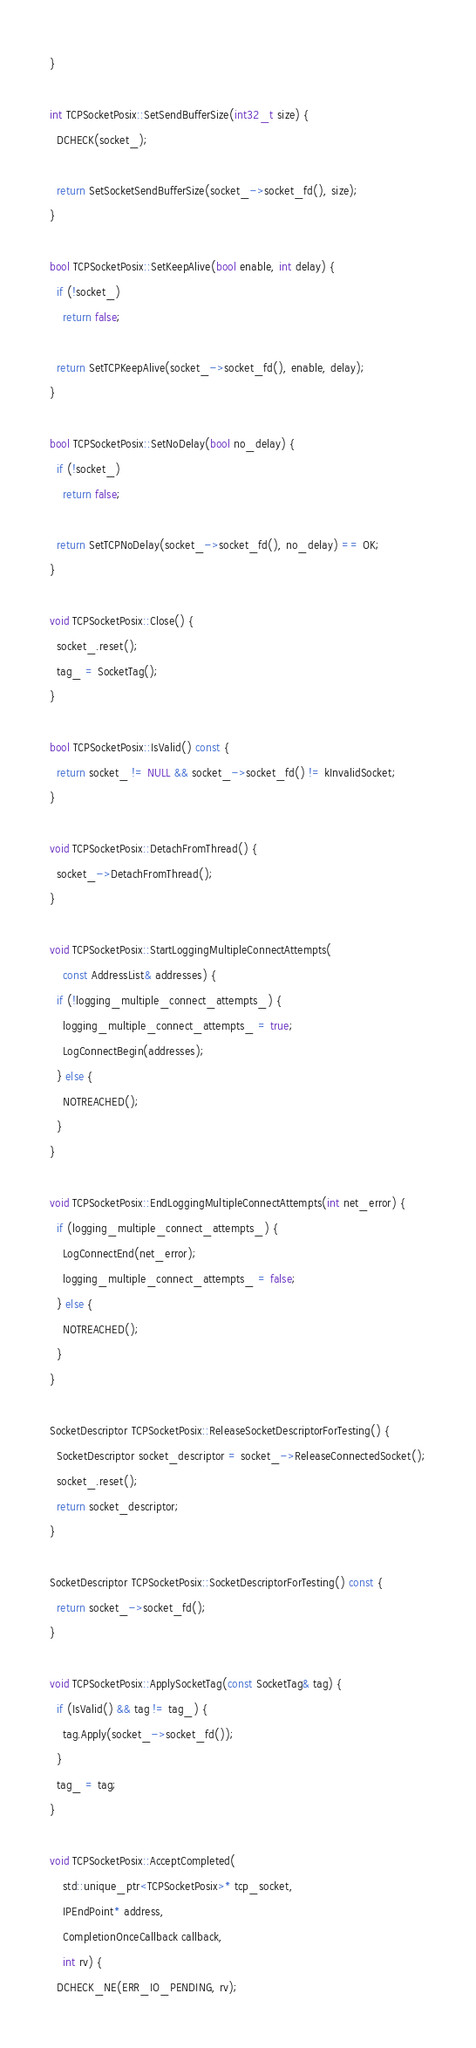<code> <loc_0><loc_0><loc_500><loc_500><_C++_>}

int TCPSocketPosix::SetSendBufferSize(int32_t size) {
  DCHECK(socket_);

  return SetSocketSendBufferSize(socket_->socket_fd(), size);
}

bool TCPSocketPosix::SetKeepAlive(bool enable, int delay) {
  if (!socket_)
    return false;

  return SetTCPKeepAlive(socket_->socket_fd(), enable, delay);
}

bool TCPSocketPosix::SetNoDelay(bool no_delay) {
  if (!socket_)
    return false;

  return SetTCPNoDelay(socket_->socket_fd(), no_delay) == OK;
}

void TCPSocketPosix::Close() {
  socket_.reset();
  tag_ = SocketTag();
}

bool TCPSocketPosix::IsValid() const {
  return socket_ != NULL && socket_->socket_fd() != kInvalidSocket;
}

void TCPSocketPosix::DetachFromThread() {
  socket_->DetachFromThread();
}

void TCPSocketPosix::StartLoggingMultipleConnectAttempts(
    const AddressList& addresses) {
  if (!logging_multiple_connect_attempts_) {
    logging_multiple_connect_attempts_ = true;
    LogConnectBegin(addresses);
  } else {
    NOTREACHED();
  }
}

void TCPSocketPosix::EndLoggingMultipleConnectAttempts(int net_error) {
  if (logging_multiple_connect_attempts_) {
    LogConnectEnd(net_error);
    logging_multiple_connect_attempts_ = false;
  } else {
    NOTREACHED();
  }
}

SocketDescriptor TCPSocketPosix::ReleaseSocketDescriptorForTesting() {
  SocketDescriptor socket_descriptor = socket_->ReleaseConnectedSocket();
  socket_.reset();
  return socket_descriptor;
}

SocketDescriptor TCPSocketPosix::SocketDescriptorForTesting() const {
  return socket_->socket_fd();
}

void TCPSocketPosix::ApplySocketTag(const SocketTag& tag) {
  if (IsValid() && tag != tag_) {
    tag.Apply(socket_->socket_fd());
  }
  tag_ = tag;
}

void TCPSocketPosix::AcceptCompleted(
    std::unique_ptr<TCPSocketPosix>* tcp_socket,
    IPEndPoint* address,
    CompletionOnceCallback callback,
    int rv) {
  DCHECK_NE(ERR_IO_PENDING, rv);</code> 